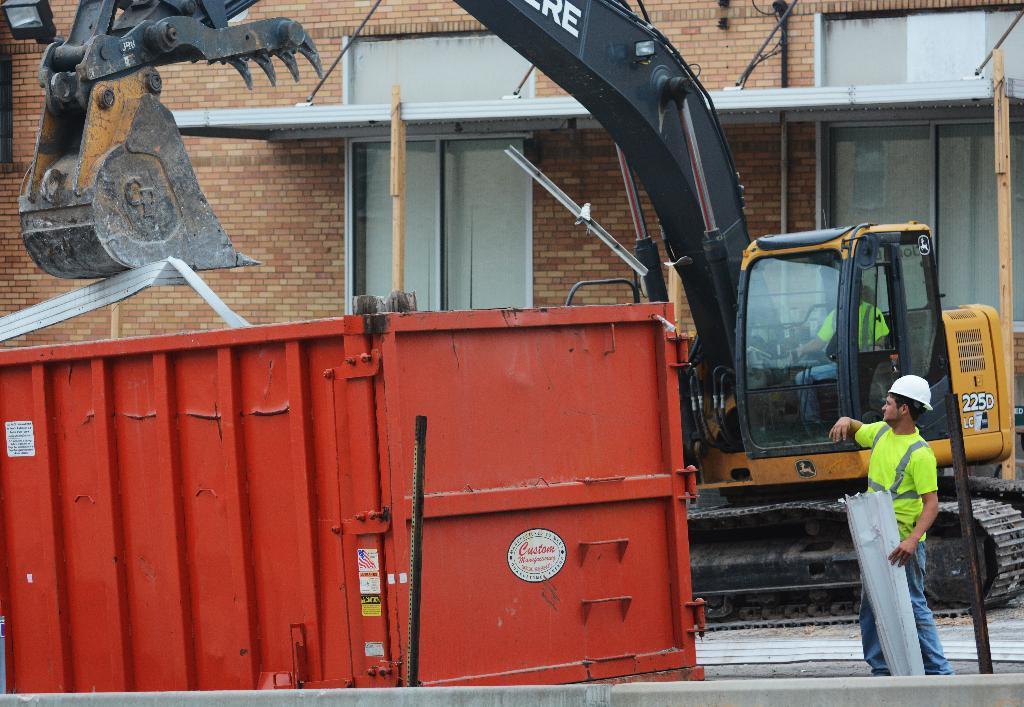Describe this image in one or two sentences. In this image, we can see a crane and a container. We can also see some people. Among them, a person is holding an object. We can see the ground and the wall with some objects. We can see some wooden poles. 